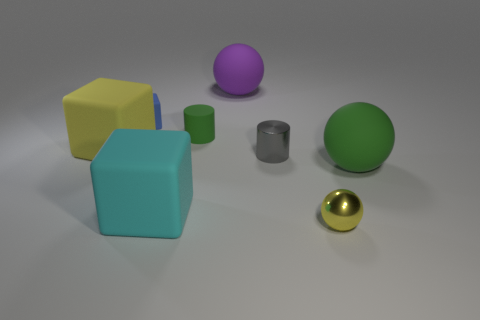What shape is the yellow thing behind the yellow thing that is on the right side of the object left of the blue rubber thing?
Offer a very short reply. Cube. There is another matte object that is the same shape as the tiny gray object; what color is it?
Your answer should be compact. Green. The large matte ball that is in front of the rubber object that is to the left of the tiny blue cube is what color?
Ensure brevity in your answer.  Green. There is a yellow rubber object that is the same shape as the blue object; what size is it?
Provide a succinct answer. Large. How many small cylinders are the same material as the large cyan thing?
Offer a terse response. 1. How many tiny rubber blocks are to the left of the rubber thing that is left of the small rubber cube?
Give a very brief answer. 0. Are there any tiny cubes on the left side of the green cylinder?
Your response must be concise. Yes. Do the green object that is in front of the gray thing and the large yellow thing have the same shape?
Keep it short and to the point. No. How many rubber balls are the same color as the matte cylinder?
Provide a succinct answer. 1. The yellow object left of the large ball that is on the left side of the metallic cylinder is what shape?
Make the answer very short. Cube. 